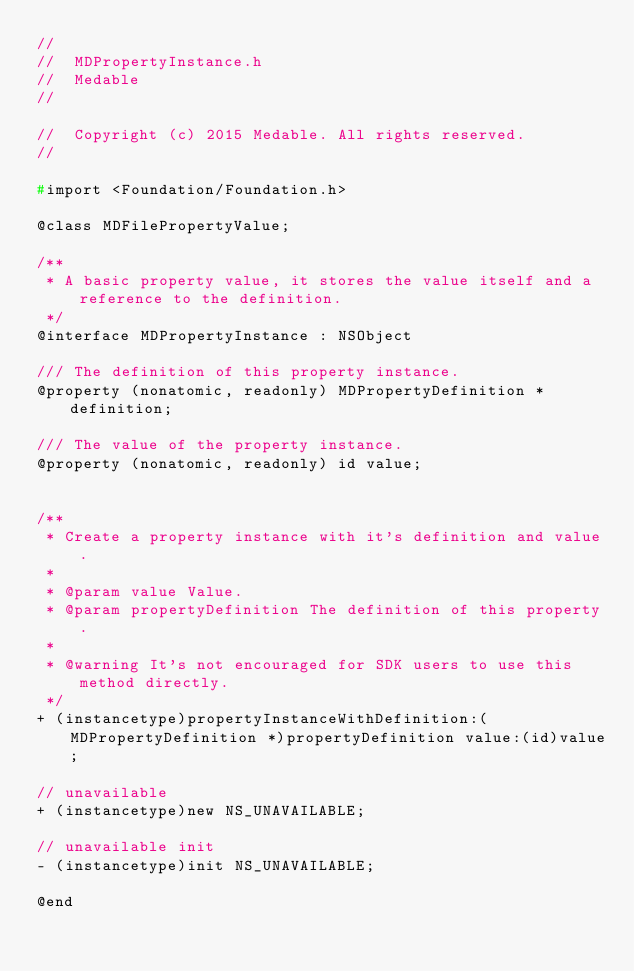<code> <loc_0><loc_0><loc_500><loc_500><_C_>//
//  MDPropertyInstance.h
//  Medable
//

//  Copyright (c) 2015 Medable. All rights reserved.
//

#import <Foundation/Foundation.h>

@class MDFilePropertyValue;

/**
 * A basic property value, it stores the value itself and a reference to the definition.
 */
@interface MDPropertyInstance : NSObject

/// The definition of this property instance.
@property (nonatomic, readonly) MDPropertyDefinition *definition;

/// The value of the property instance.
@property (nonatomic, readonly) id value;


/**
 * Create a property instance with it's definition and value.
 *
 * @param value Value.
 * @param propertyDefinition The definition of this property.
 *
 * @warning It's not encouraged for SDK users to use this method directly.
 */
+ (instancetype)propertyInstanceWithDefinition:(MDPropertyDefinition *)propertyDefinition value:(id)value;

// unavailable
+ (instancetype)new NS_UNAVAILABLE;

// unavailable init
- (instancetype)init NS_UNAVAILABLE;

@end
</code> 